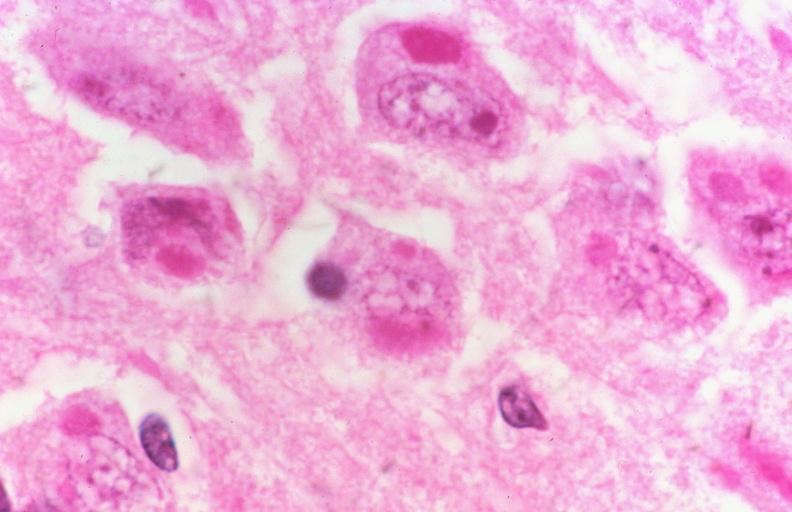does this image show rabies, negri bodies?
Answer the question using a single word or phrase. Yes 